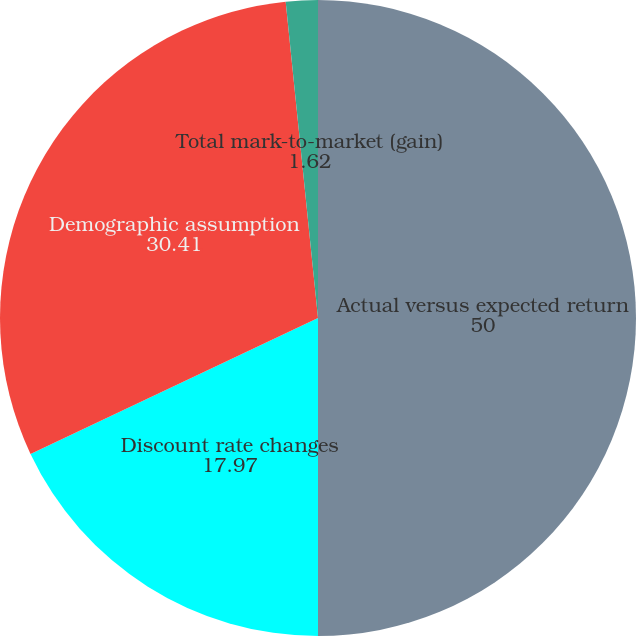Convert chart. <chart><loc_0><loc_0><loc_500><loc_500><pie_chart><fcel>Actual versus expected return<fcel>Discount rate changes<fcel>Demographic assumption<fcel>Total mark-to-market (gain)<nl><fcel>50.0%<fcel>17.97%<fcel>30.41%<fcel>1.62%<nl></chart> 